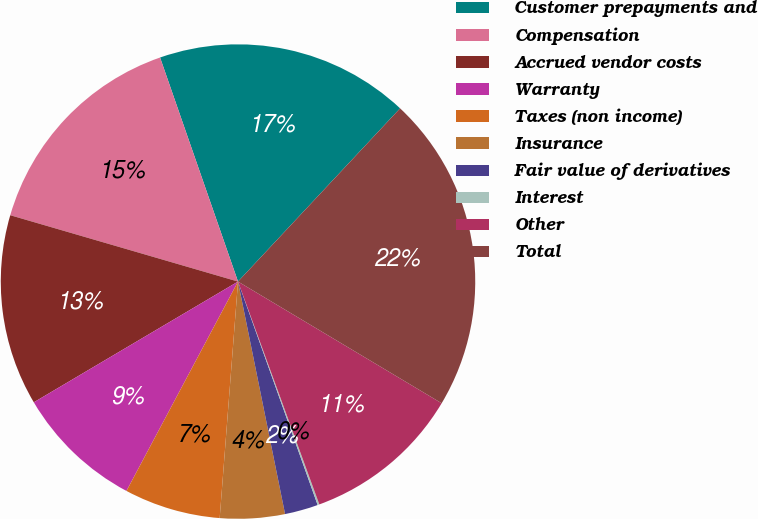<chart> <loc_0><loc_0><loc_500><loc_500><pie_chart><fcel>Customer prepayments and<fcel>Compensation<fcel>Accrued vendor costs<fcel>Warranty<fcel>Taxes (non income)<fcel>Insurance<fcel>Fair value of derivatives<fcel>Interest<fcel>Other<fcel>Total<nl><fcel>17.3%<fcel>15.16%<fcel>13.01%<fcel>8.71%<fcel>6.56%<fcel>4.41%<fcel>2.27%<fcel>0.12%<fcel>10.86%<fcel>21.6%<nl></chart> 